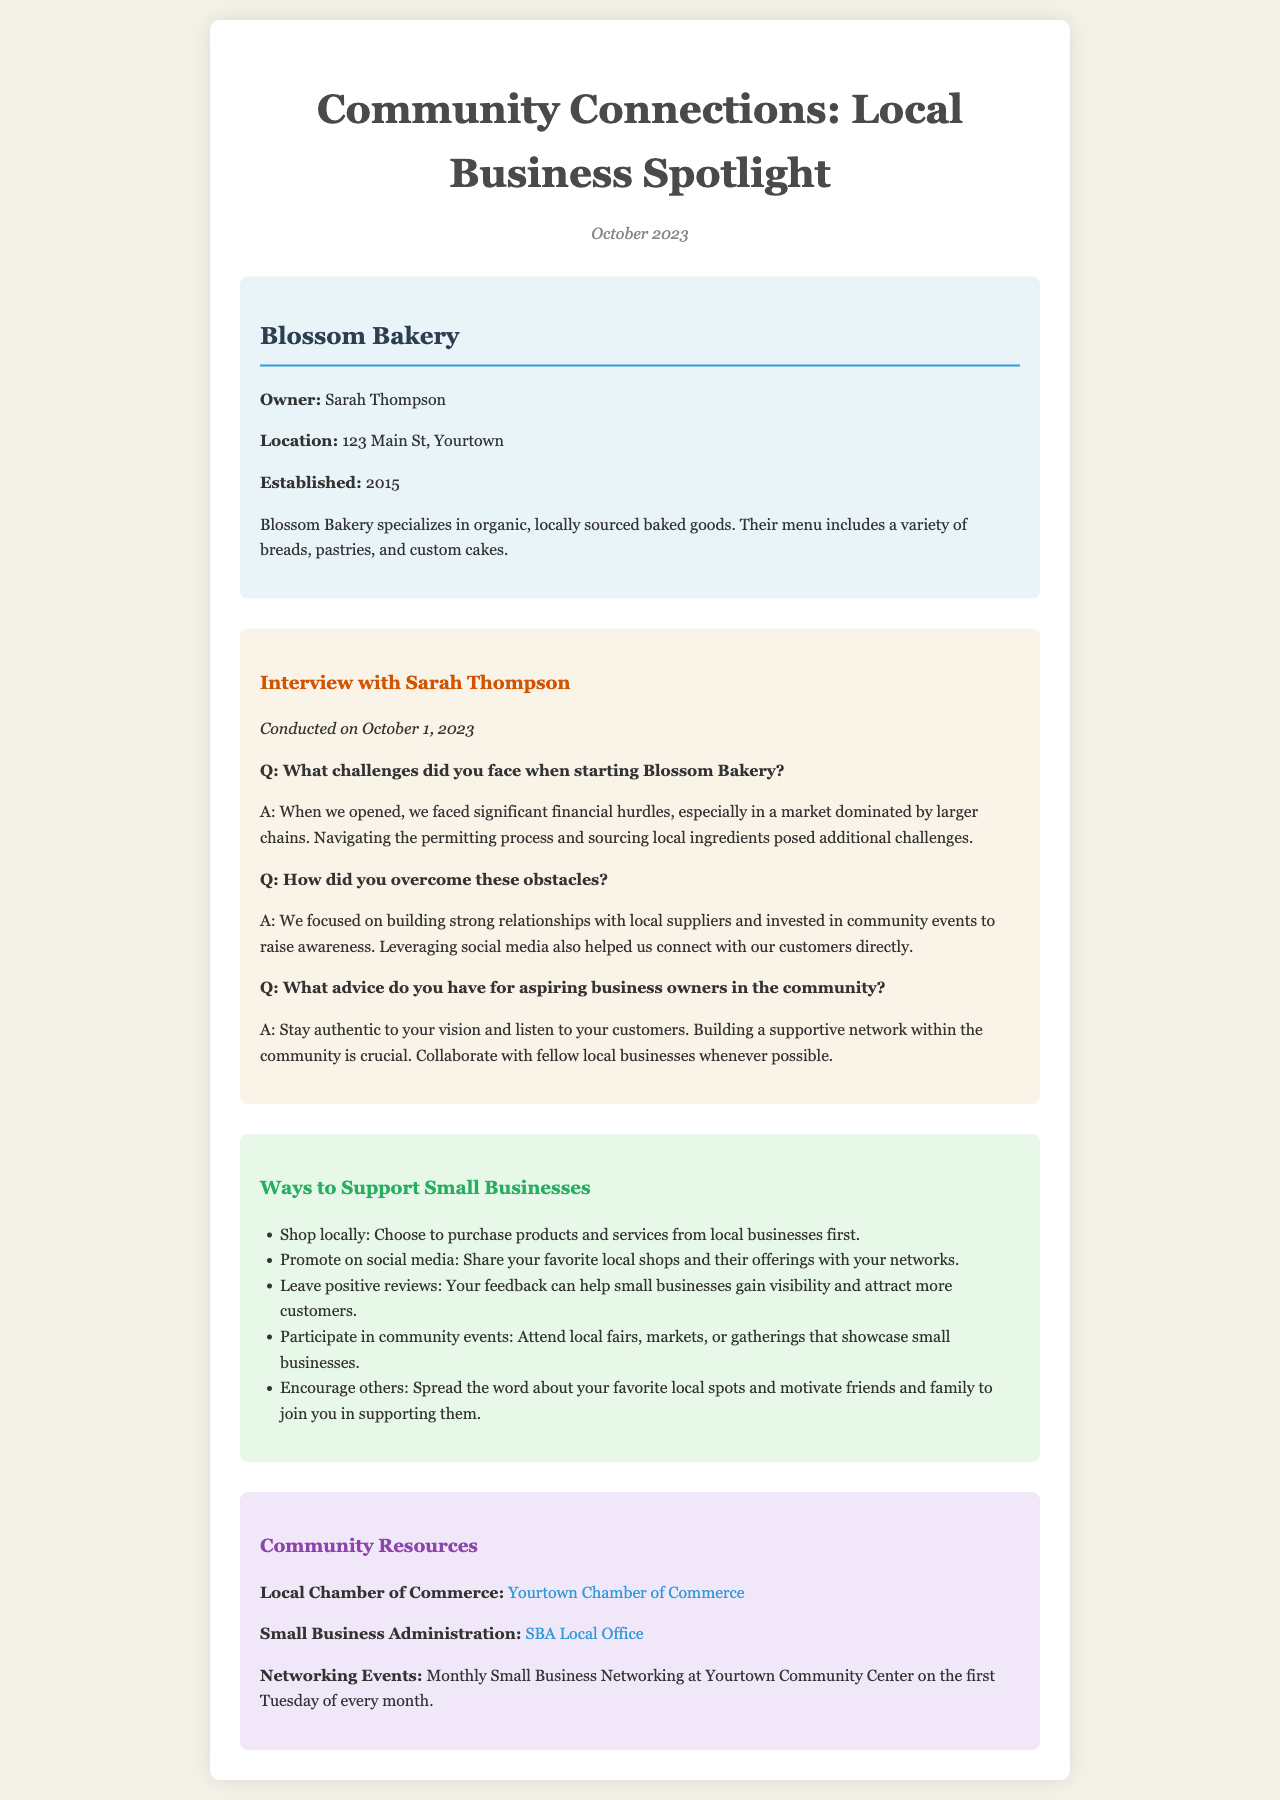What is the name of the featured business? The document explicitly states the name of the business being spotlighted, which is Blossom Bakery.
Answer: Blossom Bakery Who is the owner of Blossom Bakery? The owner of Blossom Bakery is mentioned directly in the document as Sarah Thompson.
Answer: Sarah Thompson When was Blossom Bakery established? The establishment year of Blossom Bakery is provided clearly, which is 2015.
Answer: 2015 What type of products does Blossom Bakery specialize in? The document outlines the specialty of the bakery as organic, locally sourced baked goods.
Answer: Organic, locally sourced baked goods What challenges did Sarah Thompson face when starting the business? The document explains that significant financial hurdles and challenges in the permitting process and sourcing ingredients were faced.
Answer: Financial hurdles, permitting process, sourcing ingredients What advice does Sarah Thompson offer to aspiring business owners? Sarah suggests that staying authentic to your vision and building a supportive network in the community is essential.
Answer: Stay authentic to your vision and build a supportive network List one way to support small businesses according to the document. The document provides several ways, one of which is to shop locally.
Answer: Shop locally What community resource is listed for small business assistance? The document highlights the Local Chamber of Commerce as a resource for small businesses.
Answer: Local Chamber of Commerce When are the monthly small business networking events held? The newsletter specifies that these events occur on the first Tuesday of every month.
Answer: First Tuesday of every month 